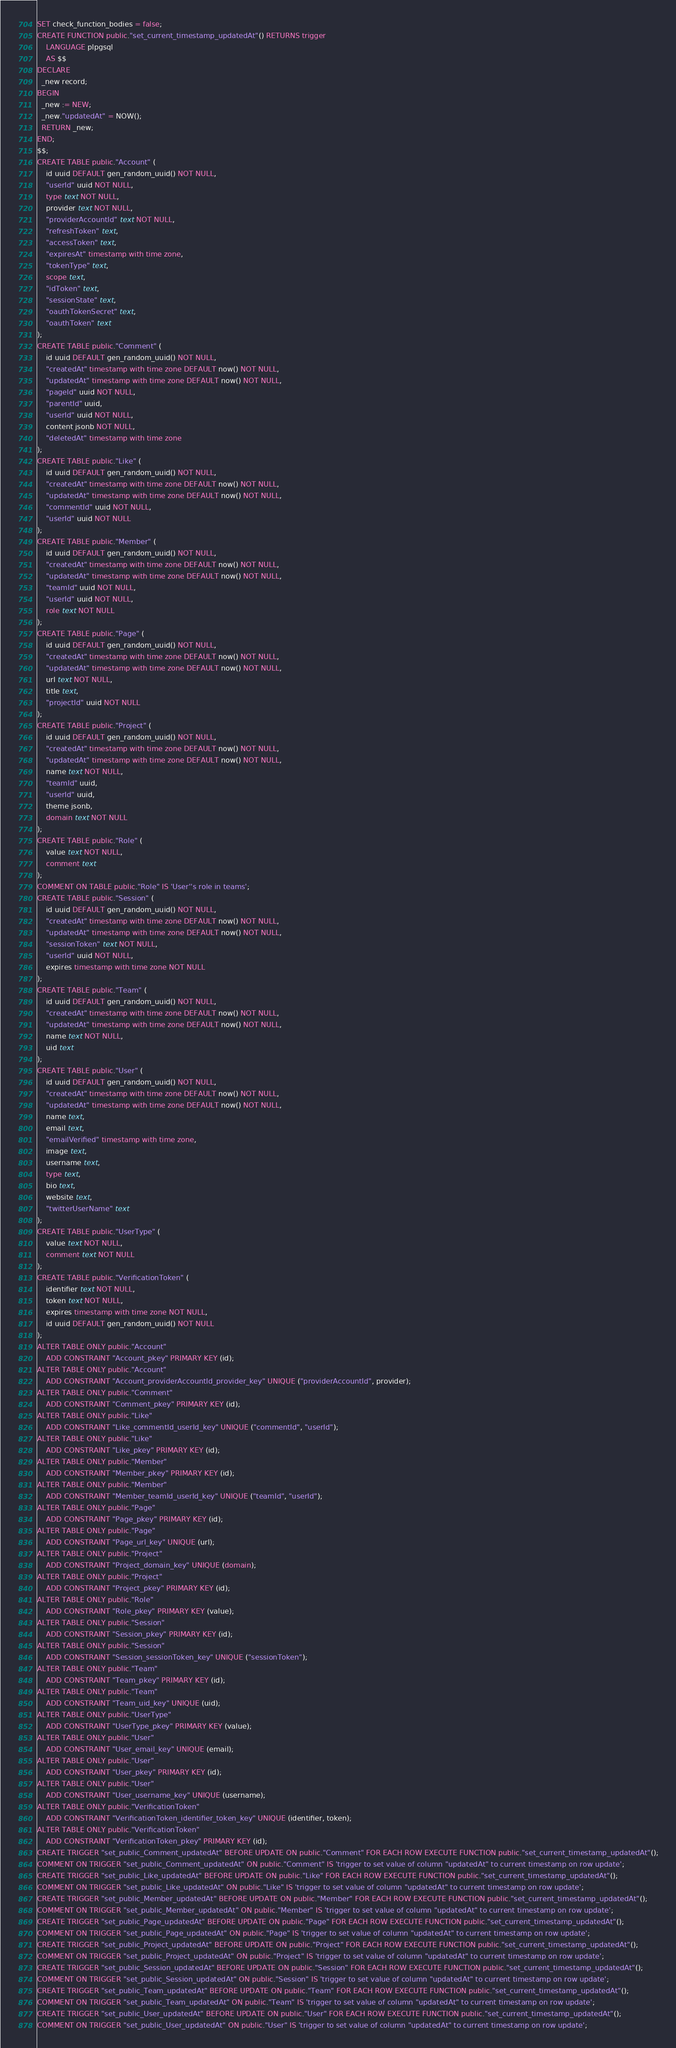<code> <loc_0><loc_0><loc_500><loc_500><_SQL_>SET check_function_bodies = false;
CREATE FUNCTION public."set_current_timestamp_updatedAt"() RETURNS trigger
    LANGUAGE plpgsql
    AS $$
DECLARE
  _new record;
BEGIN
  _new := NEW;
  _new."updatedAt" = NOW();
  RETURN _new;
END;
$$;
CREATE TABLE public."Account" (
    id uuid DEFAULT gen_random_uuid() NOT NULL,
    "userId" uuid NOT NULL,
    type text NOT NULL,
    provider text NOT NULL,
    "providerAccountId" text NOT NULL,
    "refreshToken" text,
    "accessToken" text,
    "expiresAt" timestamp with time zone,
    "tokenType" text,
    scope text,
    "idToken" text,
    "sessionState" text,
    "oauthTokenSecret" text,
    "oauthToken" text
);
CREATE TABLE public."Comment" (
    id uuid DEFAULT gen_random_uuid() NOT NULL,
    "createdAt" timestamp with time zone DEFAULT now() NOT NULL,
    "updatedAt" timestamp with time zone DEFAULT now() NOT NULL,
    "pageId" uuid NOT NULL,
    "parentId" uuid,
    "userId" uuid NOT NULL,
    content jsonb NOT NULL,
    "deletedAt" timestamp with time zone
);
CREATE TABLE public."Like" (
    id uuid DEFAULT gen_random_uuid() NOT NULL,
    "createdAt" timestamp with time zone DEFAULT now() NOT NULL,
    "updatedAt" timestamp with time zone DEFAULT now() NOT NULL,
    "commentId" uuid NOT NULL,
    "userId" uuid NOT NULL
);
CREATE TABLE public."Member" (
    id uuid DEFAULT gen_random_uuid() NOT NULL,
    "createdAt" timestamp with time zone DEFAULT now() NOT NULL,
    "updatedAt" timestamp with time zone DEFAULT now() NOT NULL,
    "teamId" uuid NOT NULL,
    "userId" uuid NOT NULL,
    role text NOT NULL
);
CREATE TABLE public."Page" (
    id uuid DEFAULT gen_random_uuid() NOT NULL,
    "createdAt" timestamp with time zone DEFAULT now() NOT NULL,
    "updatedAt" timestamp with time zone DEFAULT now() NOT NULL,
    url text NOT NULL,
    title text,
    "projectId" uuid NOT NULL
);
CREATE TABLE public."Project" (
    id uuid DEFAULT gen_random_uuid() NOT NULL,
    "createdAt" timestamp with time zone DEFAULT now() NOT NULL,
    "updatedAt" timestamp with time zone DEFAULT now() NOT NULL,
    name text NOT NULL,
    "teamId" uuid,
    "userId" uuid,
    theme jsonb,
    domain text NOT NULL
);
CREATE TABLE public."Role" (
    value text NOT NULL,
    comment text
);
COMMENT ON TABLE public."Role" IS 'User''s role in teams';
CREATE TABLE public."Session" (
    id uuid DEFAULT gen_random_uuid() NOT NULL,
    "createdAt" timestamp with time zone DEFAULT now() NOT NULL,
    "updatedAt" timestamp with time zone DEFAULT now() NOT NULL,
    "sessionToken" text NOT NULL,
    "userId" uuid NOT NULL,
    expires timestamp with time zone NOT NULL
);
CREATE TABLE public."Team" (
    id uuid DEFAULT gen_random_uuid() NOT NULL,
    "createdAt" timestamp with time zone DEFAULT now() NOT NULL,
    "updatedAt" timestamp with time zone DEFAULT now() NOT NULL,
    name text NOT NULL,
    uid text
);
CREATE TABLE public."User" (
    id uuid DEFAULT gen_random_uuid() NOT NULL,
    "createdAt" timestamp with time zone DEFAULT now() NOT NULL,
    "updatedAt" timestamp with time zone DEFAULT now() NOT NULL,
    name text,
    email text,
    "emailVerified" timestamp with time zone,
    image text,
    username text,
    type text,
    bio text,
    website text,
    "twitterUserName" text
);
CREATE TABLE public."UserType" (
    value text NOT NULL,
    comment text NOT NULL
);
CREATE TABLE public."VerificationToken" (
    identifier text NOT NULL,
    token text NOT NULL,
    expires timestamp with time zone NOT NULL,
    id uuid DEFAULT gen_random_uuid() NOT NULL
);
ALTER TABLE ONLY public."Account"
    ADD CONSTRAINT "Account_pkey" PRIMARY KEY (id);
ALTER TABLE ONLY public."Account"
    ADD CONSTRAINT "Account_providerAccountId_provider_key" UNIQUE ("providerAccountId", provider);
ALTER TABLE ONLY public."Comment"
    ADD CONSTRAINT "Comment_pkey" PRIMARY KEY (id);
ALTER TABLE ONLY public."Like"
    ADD CONSTRAINT "Like_commentId_userId_key" UNIQUE ("commentId", "userId");
ALTER TABLE ONLY public."Like"
    ADD CONSTRAINT "Like_pkey" PRIMARY KEY (id);
ALTER TABLE ONLY public."Member"
    ADD CONSTRAINT "Member_pkey" PRIMARY KEY (id);
ALTER TABLE ONLY public."Member"
    ADD CONSTRAINT "Member_teamId_userId_key" UNIQUE ("teamId", "userId");
ALTER TABLE ONLY public."Page"
    ADD CONSTRAINT "Page_pkey" PRIMARY KEY (id);
ALTER TABLE ONLY public."Page"
    ADD CONSTRAINT "Page_url_key" UNIQUE (url);
ALTER TABLE ONLY public."Project"
    ADD CONSTRAINT "Project_domain_key" UNIQUE (domain);
ALTER TABLE ONLY public."Project"
    ADD CONSTRAINT "Project_pkey" PRIMARY KEY (id);
ALTER TABLE ONLY public."Role"
    ADD CONSTRAINT "Role_pkey" PRIMARY KEY (value);
ALTER TABLE ONLY public."Session"
    ADD CONSTRAINT "Session_pkey" PRIMARY KEY (id);
ALTER TABLE ONLY public."Session"
    ADD CONSTRAINT "Session_sessionToken_key" UNIQUE ("sessionToken");
ALTER TABLE ONLY public."Team"
    ADD CONSTRAINT "Team_pkey" PRIMARY KEY (id);
ALTER TABLE ONLY public."Team"
    ADD CONSTRAINT "Team_uid_key" UNIQUE (uid);
ALTER TABLE ONLY public."UserType"
    ADD CONSTRAINT "UserType_pkey" PRIMARY KEY (value);
ALTER TABLE ONLY public."User"
    ADD CONSTRAINT "User_email_key" UNIQUE (email);
ALTER TABLE ONLY public."User"
    ADD CONSTRAINT "User_pkey" PRIMARY KEY (id);
ALTER TABLE ONLY public."User"
    ADD CONSTRAINT "User_username_key" UNIQUE (username);
ALTER TABLE ONLY public."VerificationToken"
    ADD CONSTRAINT "VerificationToken_identifier_token_key" UNIQUE (identifier, token);
ALTER TABLE ONLY public."VerificationToken"
    ADD CONSTRAINT "VerificationToken_pkey" PRIMARY KEY (id);
CREATE TRIGGER "set_public_Comment_updatedAt" BEFORE UPDATE ON public."Comment" FOR EACH ROW EXECUTE FUNCTION public."set_current_timestamp_updatedAt"();
COMMENT ON TRIGGER "set_public_Comment_updatedAt" ON public."Comment" IS 'trigger to set value of column "updatedAt" to current timestamp on row update';
CREATE TRIGGER "set_public_Like_updatedAt" BEFORE UPDATE ON public."Like" FOR EACH ROW EXECUTE FUNCTION public."set_current_timestamp_updatedAt"();
COMMENT ON TRIGGER "set_public_Like_updatedAt" ON public."Like" IS 'trigger to set value of column "updatedAt" to current timestamp on row update';
CREATE TRIGGER "set_public_Member_updatedAt" BEFORE UPDATE ON public."Member" FOR EACH ROW EXECUTE FUNCTION public."set_current_timestamp_updatedAt"();
COMMENT ON TRIGGER "set_public_Member_updatedAt" ON public."Member" IS 'trigger to set value of column "updatedAt" to current timestamp on row update';
CREATE TRIGGER "set_public_Page_updatedAt" BEFORE UPDATE ON public."Page" FOR EACH ROW EXECUTE FUNCTION public."set_current_timestamp_updatedAt"();
COMMENT ON TRIGGER "set_public_Page_updatedAt" ON public."Page" IS 'trigger to set value of column "updatedAt" to current timestamp on row update';
CREATE TRIGGER "set_public_Project_updatedAt" BEFORE UPDATE ON public."Project" FOR EACH ROW EXECUTE FUNCTION public."set_current_timestamp_updatedAt"();
COMMENT ON TRIGGER "set_public_Project_updatedAt" ON public."Project" IS 'trigger to set value of column "updatedAt" to current timestamp on row update';
CREATE TRIGGER "set_public_Session_updatedAt" BEFORE UPDATE ON public."Session" FOR EACH ROW EXECUTE FUNCTION public."set_current_timestamp_updatedAt"();
COMMENT ON TRIGGER "set_public_Session_updatedAt" ON public."Session" IS 'trigger to set value of column "updatedAt" to current timestamp on row update';
CREATE TRIGGER "set_public_Team_updatedAt" BEFORE UPDATE ON public."Team" FOR EACH ROW EXECUTE FUNCTION public."set_current_timestamp_updatedAt"();
COMMENT ON TRIGGER "set_public_Team_updatedAt" ON public."Team" IS 'trigger to set value of column "updatedAt" to current timestamp on row update';
CREATE TRIGGER "set_public_User_updatedAt" BEFORE UPDATE ON public."User" FOR EACH ROW EXECUTE FUNCTION public."set_current_timestamp_updatedAt"();
COMMENT ON TRIGGER "set_public_User_updatedAt" ON public."User" IS 'trigger to set value of column "updatedAt" to current timestamp on row update';</code> 